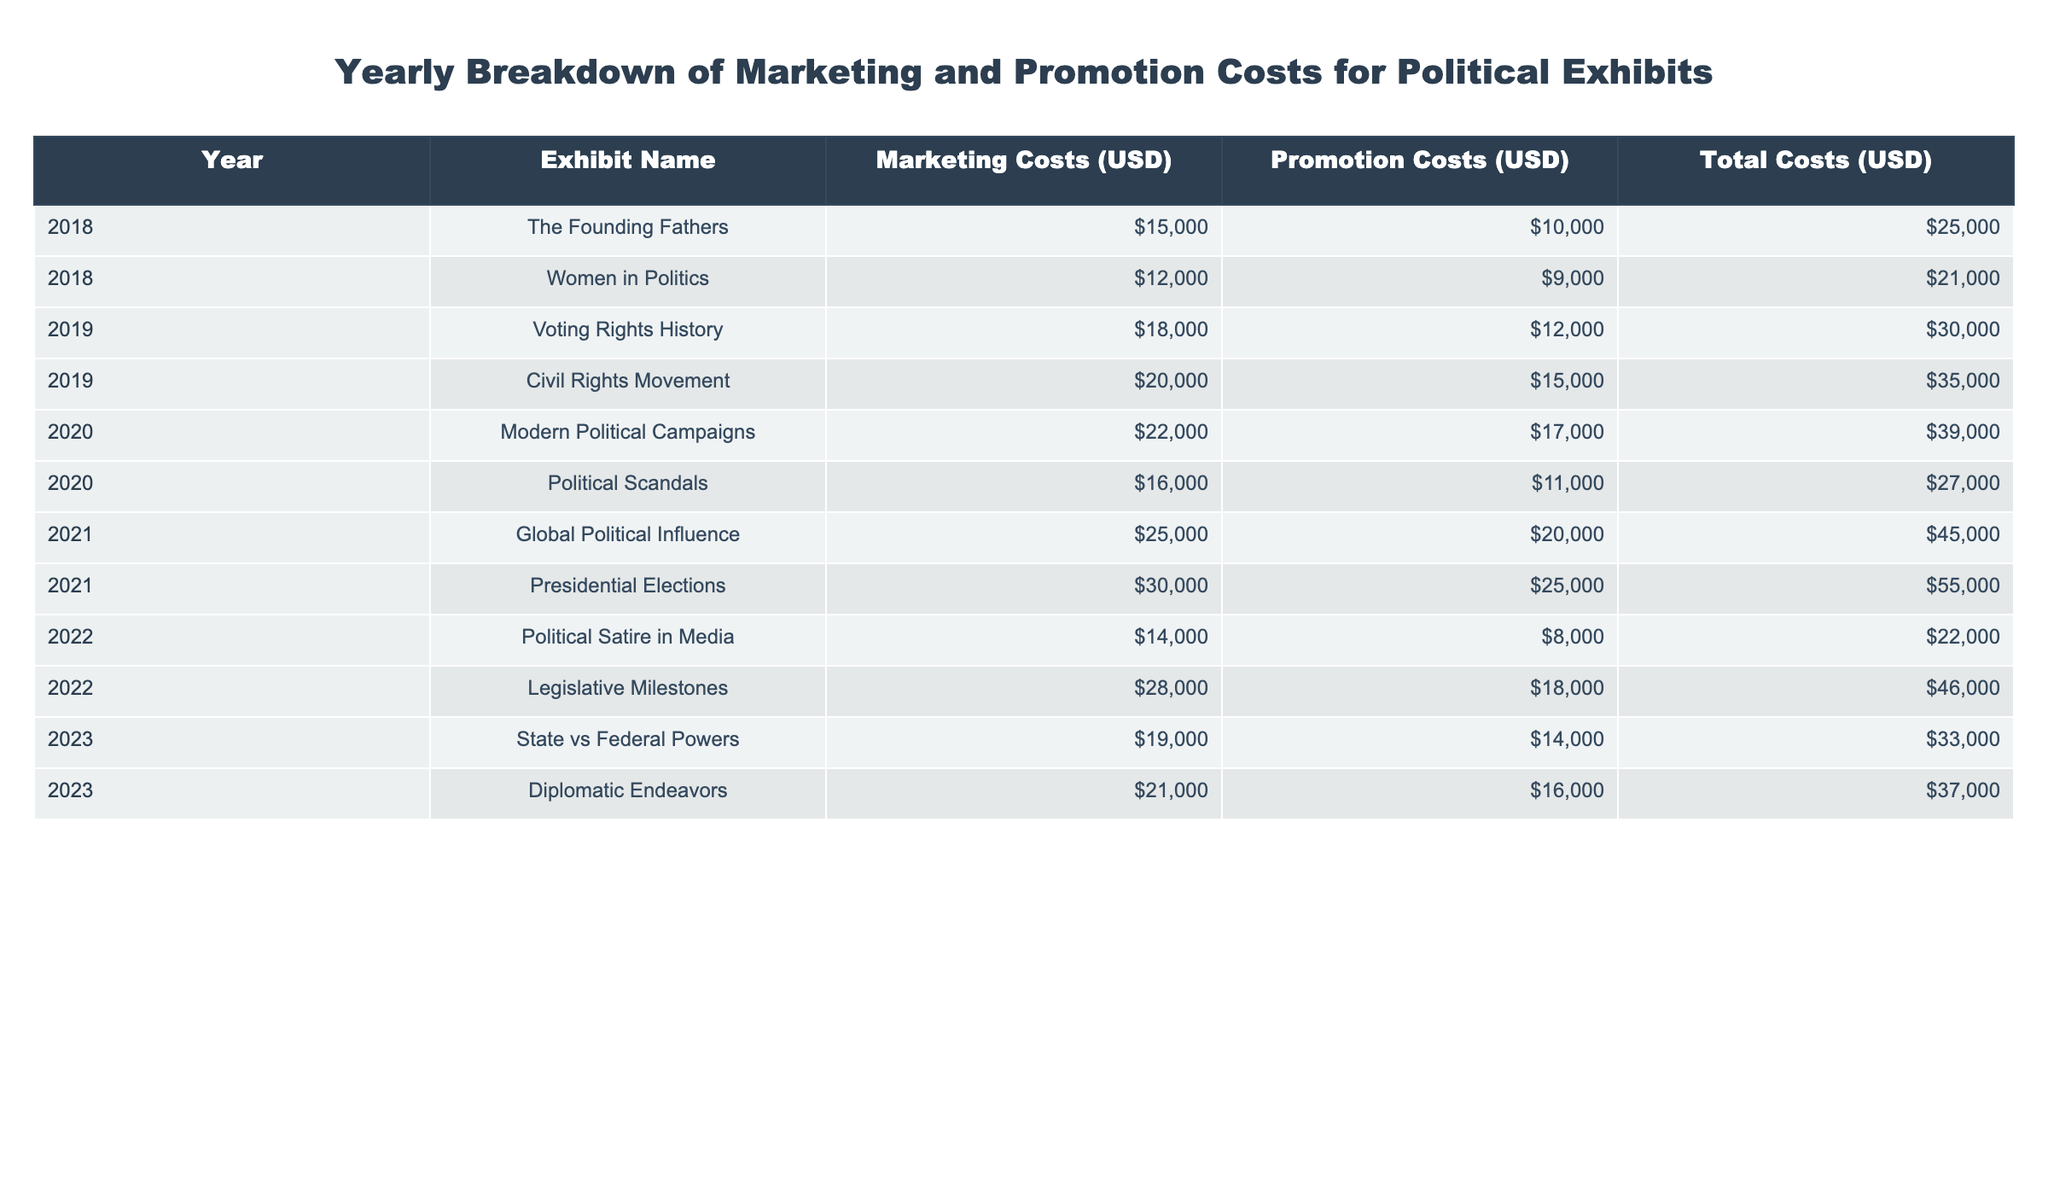What was the total marketing cost for the exhibit "Women in Politics" in 2018? The marketing cost for "Women in Politics" in 2018 is explicitly listed in the table under the Marketing Costs column. It shows 12000 USD for that exhibit in that year.
Answer: 12000 USD Which exhibit in 2021 had the highest total costs? To find the exhibit with the highest total costs in 2021, we compare the Total Costs values for the exhibits in that year. "Presidential Elections" has a total cost of 55000 USD, which is higher than the other exhibit "Global Political Influence" with 45000 USD.
Answer: Presidential Elections What is the total marketing cost across all exhibits in 2020? The marketing costs for the exhibits in 2020 are 22000 USD for "Modern Political Campaigns" and 16000 USD for "Political Scandals". Summing these gives 22000 + 16000 = 38000 USD.
Answer: 38000 USD Did the "Voting Rights History" exhibit have a higher promotion cost than the "Civil Rights Movement" exhibit in 2019? Looking at the Promotion Costs for both exhibits, "Voting Rights History" has a cost of 12000 USD, while "Civil Rights Movement" has a cost of 15000 USD. Since 12000 is less than 15000, the statement is false.
Answer: No What was the average total cost per exhibit for the year 2022? In 2022, there are two exhibits: "Political Satire in Media" with total costs of 22000 USD and "Legislative Milestones" with total costs of 46000 USD. The total costs for 2022 is 22000 + 46000 = 68000 USD. Dividing this by the number of exhibits (2) gives 68000 / 2 = 34000 USD.
Answer: 34000 USD Which year had the lowest total costs for all exhibits combined? To determine the year with the lowest total costs, we need to sum the Total Costs for all exhibits within each year. 2018 totals 25000 + 21000 = 46000, 2019 totals 30000 + 35000 = 65000, 2020 totals 39000 + 27000 = 66000, 2021 totals 45000 + 55000 = 100000, 2022 totals 22000 + 46000 = 68000, and 2023 totals 33000 + 37000 = 70000. The lowest total is 46000 in 2018.
Answer: 2018 What are the total costs for the "State vs Federal Powers" exhibit? The total costs for the "State vs Federal Powers" exhibit is directly provided in the table under Total Costs and is listed as 33000 USD.
Answer: 33000 USD Was the promotional cost for the "Diplomatic Endeavors" exhibit greater than the marketing cost for the same year? For the year 2023, the promotional cost for "Diplomatic Endeavors" is 16000 USD and the marketing cost is 21000 USD. Since 16000 is less than 21000, the statement is false.
Answer: No 